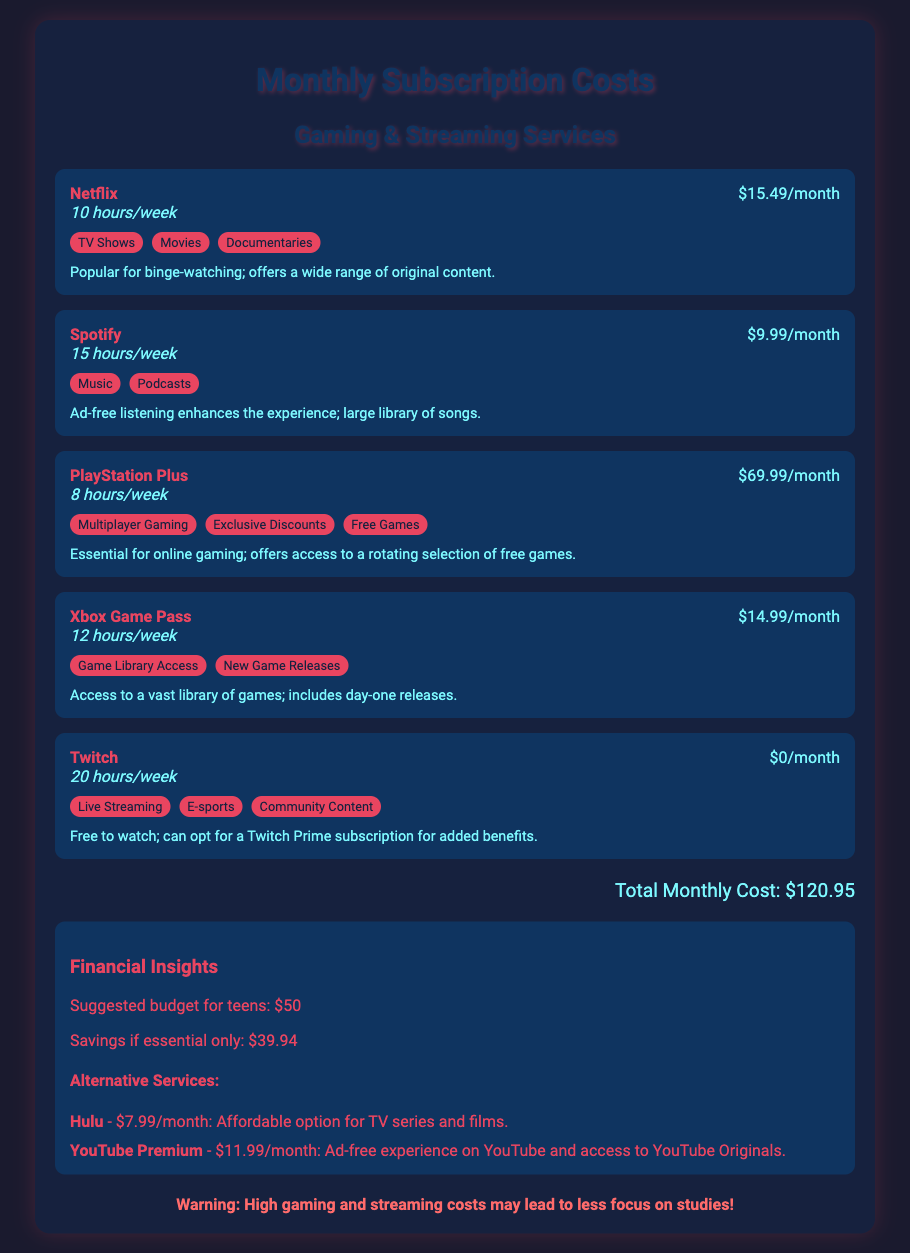What is the total monthly cost? The total monthly cost is mentioned at the bottom of the document, which adds up the costs of all listed subscriptions.
Answer: $120.95 How much is the Netflix subscription? The price for Netflix is clearly listed in the service card, making it easy to find.
Answer: $15.49/month What service offers free access? The document states that Twitch is free to watch, highlighting its cost structure.
Answer: Twitch Which service has the highest usage hours? Usage hours are listed for each service, and comparing them indicates which has the most.
Answer: Twitch (20 hours/week) How much can a teen save if only essential services are used? The document suggests a potential savings amount based on the budget vs total cost of subscriptions.
Answer: $39.94 What is the monthly cost of Spotify? The price for Spotify is provided in its respective service card for easy reference.
Answer: $9.99/month What alternative service is mentioned along with its cost? Any alternative service mentioned is accompanied by its pricing, showing potential options.
Answer: Hulu - $7.99/month What is the recommended budget for teens? The financial insights section provides a specific budget suggestion for teenagers.
Answer: $50 What type of content does PlayStation Plus include? Content types are listed under each service, which indicate what can be accessed or played.
Answer: Multiplayer Gaming 